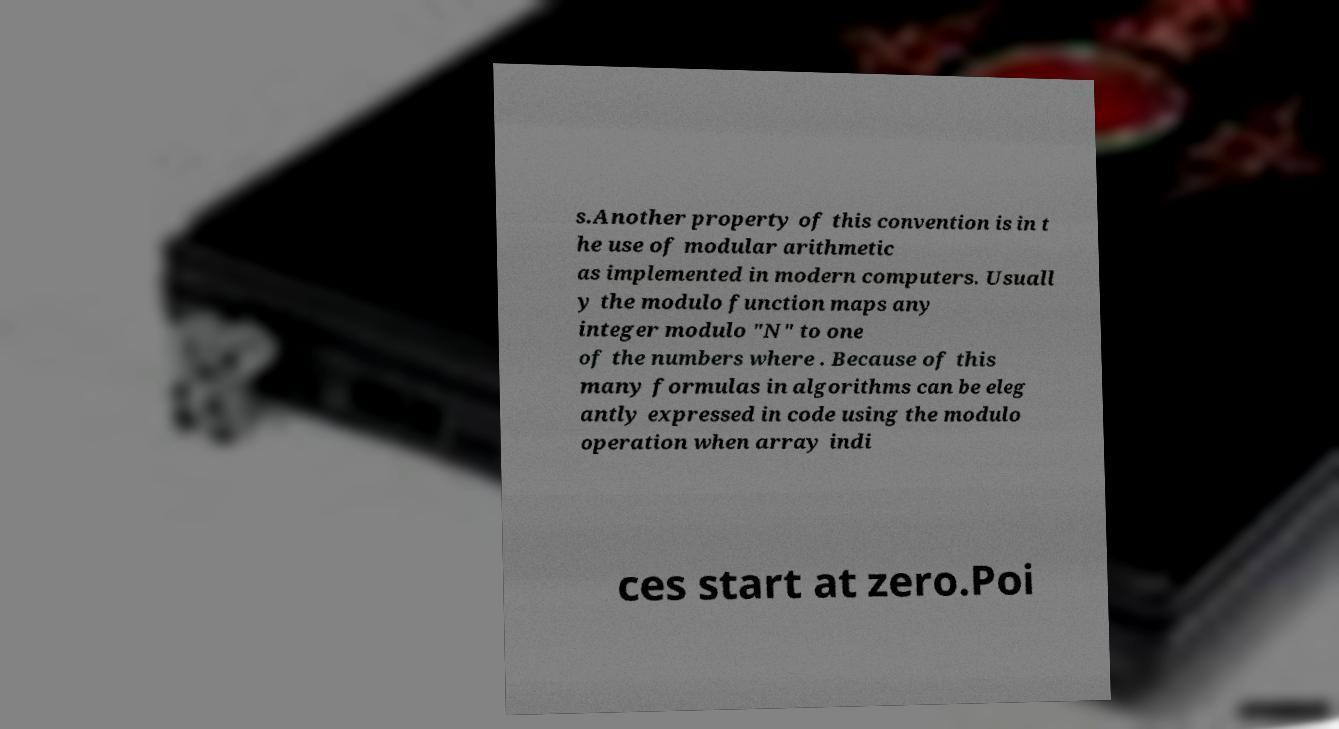I need the written content from this picture converted into text. Can you do that? s.Another property of this convention is in t he use of modular arithmetic as implemented in modern computers. Usuall y the modulo function maps any integer modulo "N" to one of the numbers where . Because of this many formulas in algorithms can be eleg antly expressed in code using the modulo operation when array indi ces start at zero.Poi 